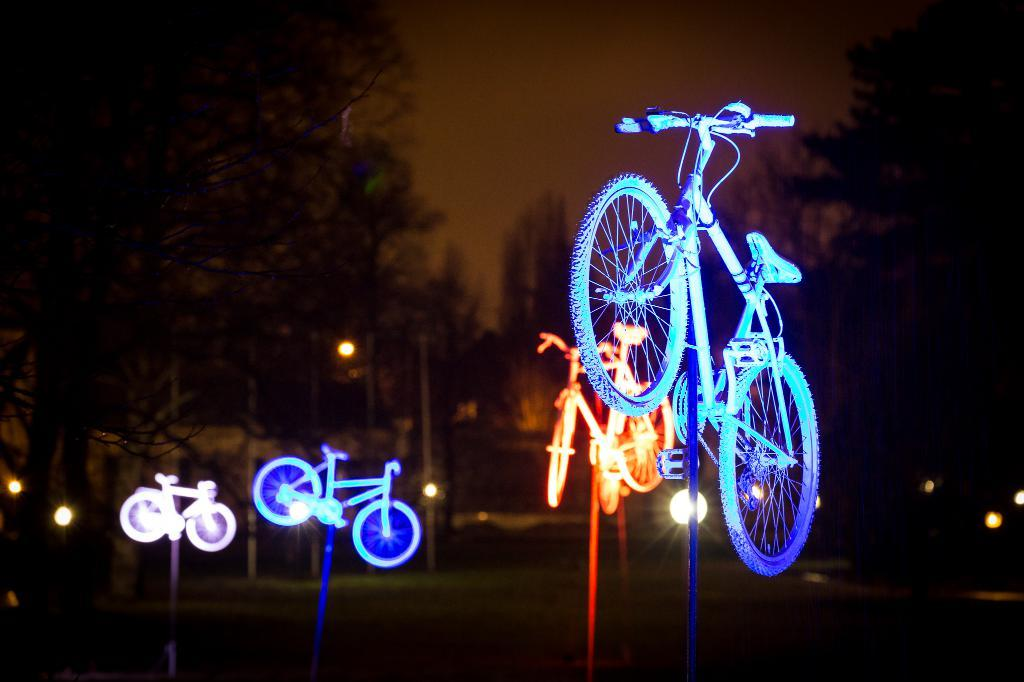What is the lighting condition in the image? The image was taken in the dark. What can be seen in the image besides the lighting condition? There are bicycles in the image. What is visible in the background of the image? There are lights and trees visible in the background of the image. What type of knee injury is mentioned on the receipt in the image? There is no receipt present in the image, and therefore no mention of a knee injury. 